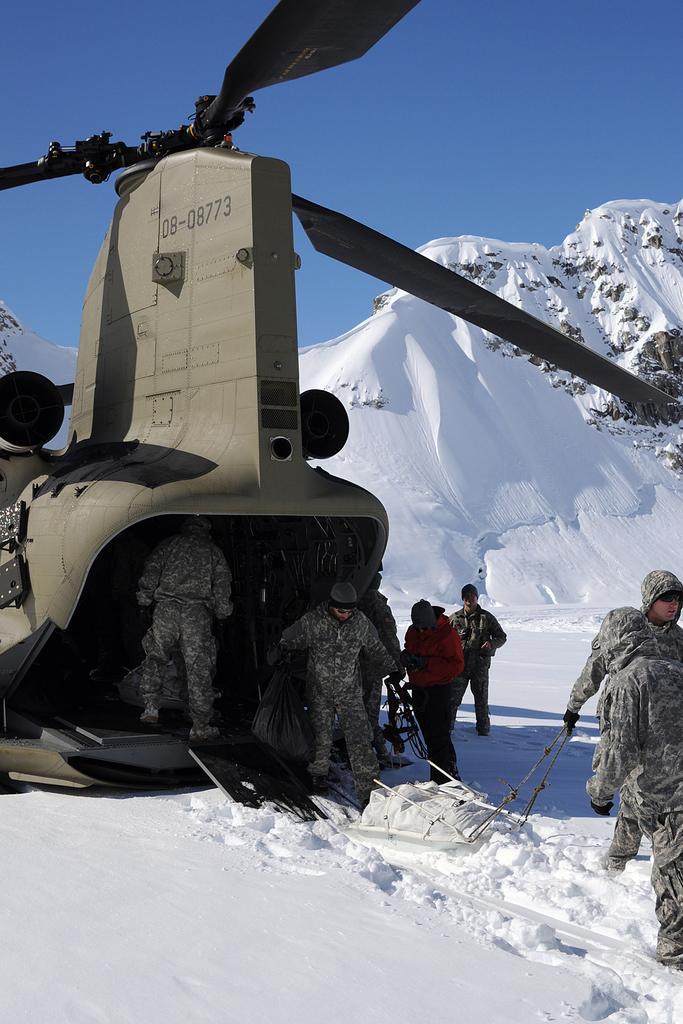Can you describe this image briefly? In the picture we can see a chopper and some people are getting down from it on the snow surface and they are wearing a uniform with caps, gloves and in the background, we can see a hill covered with snow and behind it we can see a sky. 